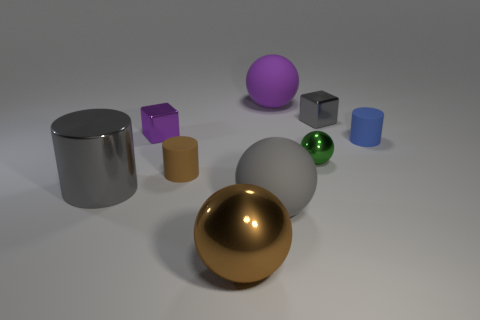Subtract all gray spheres. How many spheres are left? 3 Add 1 large brown things. How many objects exist? 10 Subtract all cylinders. How many objects are left? 6 Subtract all blue cylinders. How many cylinders are left? 2 Add 7 green metal objects. How many green metal objects exist? 8 Subtract 0 brown cubes. How many objects are left? 9 Subtract all cyan cylinders. Subtract all green spheres. How many cylinders are left? 3 Subtract all yellow cylinders. How many green cubes are left? 0 Subtract all big green metal balls. Subtract all large cylinders. How many objects are left? 8 Add 6 gray shiny cubes. How many gray shiny cubes are left? 7 